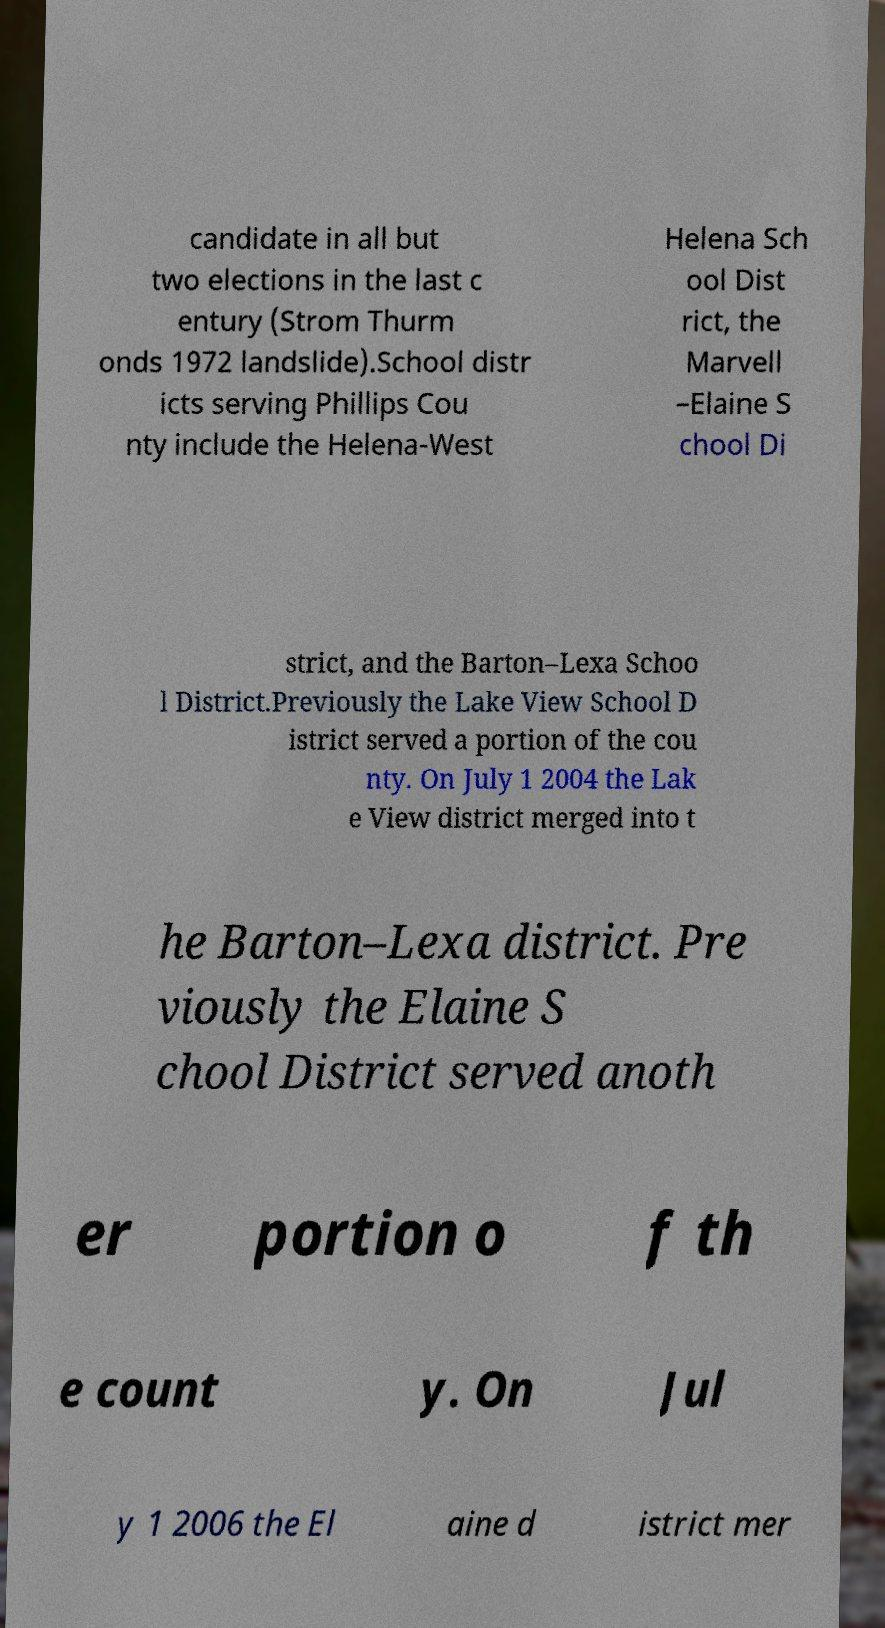I need the written content from this picture converted into text. Can you do that? candidate in all but two elections in the last c entury (Strom Thurm onds 1972 landslide).School distr icts serving Phillips Cou nty include the Helena-West Helena Sch ool Dist rict, the Marvell –Elaine S chool Di strict, and the Barton–Lexa Schoo l District.Previously the Lake View School D istrict served a portion of the cou nty. On July 1 2004 the Lak e View district merged into t he Barton–Lexa district. Pre viously the Elaine S chool District served anoth er portion o f th e count y. On Jul y 1 2006 the El aine d istrict mer 